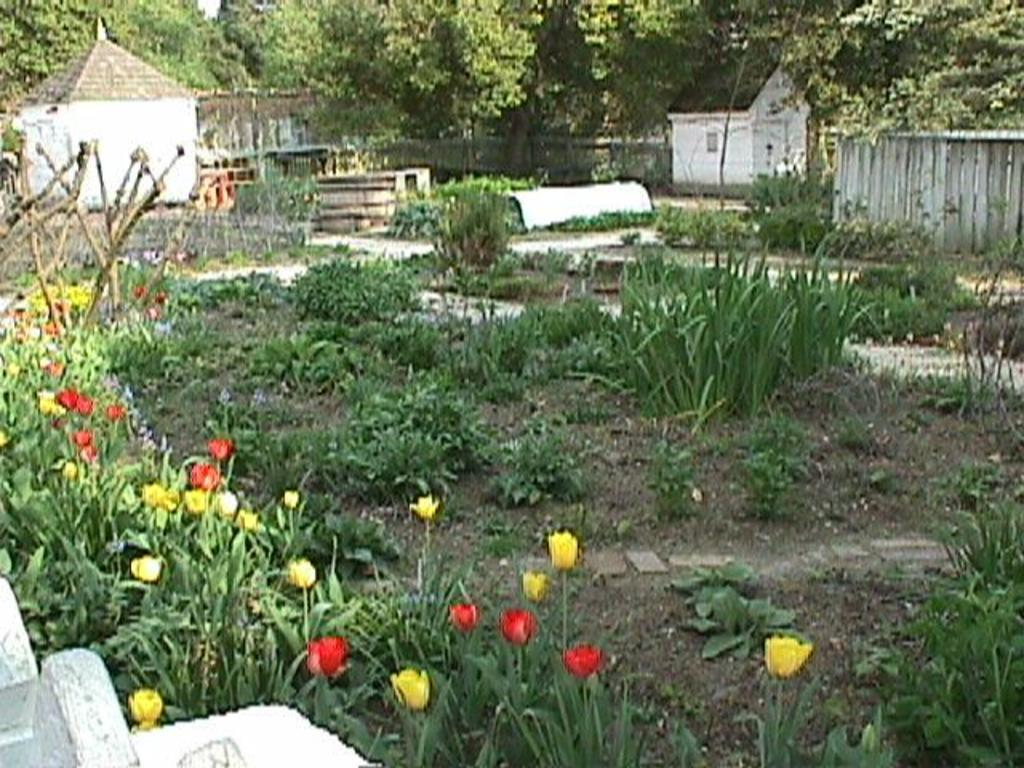What type of structures can be seen in the image? There are houses in the image. What natural elements are present in the image? There are many trees and plants in the image. Are there any flowers visible in the image? Yes, flowers are present on the plants in the image. What type of barrier can be seen in the image? There is a fence in the image. What hobbies do the houses in the image engage in? Houses do not engage in hobbies, as they are inanimate structures. Can you see any wings on the trees in the image? There are no wings present on the trees in the image; trees do not have wings. 